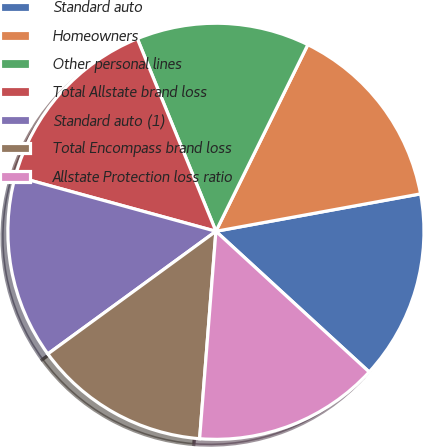Convert chart to OTSL. <chart><loc_0><loc_0><loc_500><loc_500><pie_chart><fcel>Standard auto<fcel>Homeowners<fcel>Other personal lines<fcel>Total Allstate brand loss<fcel>Standard auto (1)<fcel>Total Encompass brand loss<fcel>Allstate Protection loss ratio<nl><fcel>14.7%<fcel>14.84%<fcel>13.45%<fcel>14.57%<fcel>14.3%<fcel>13.72%<fcel>14.43%<nl></chart> 